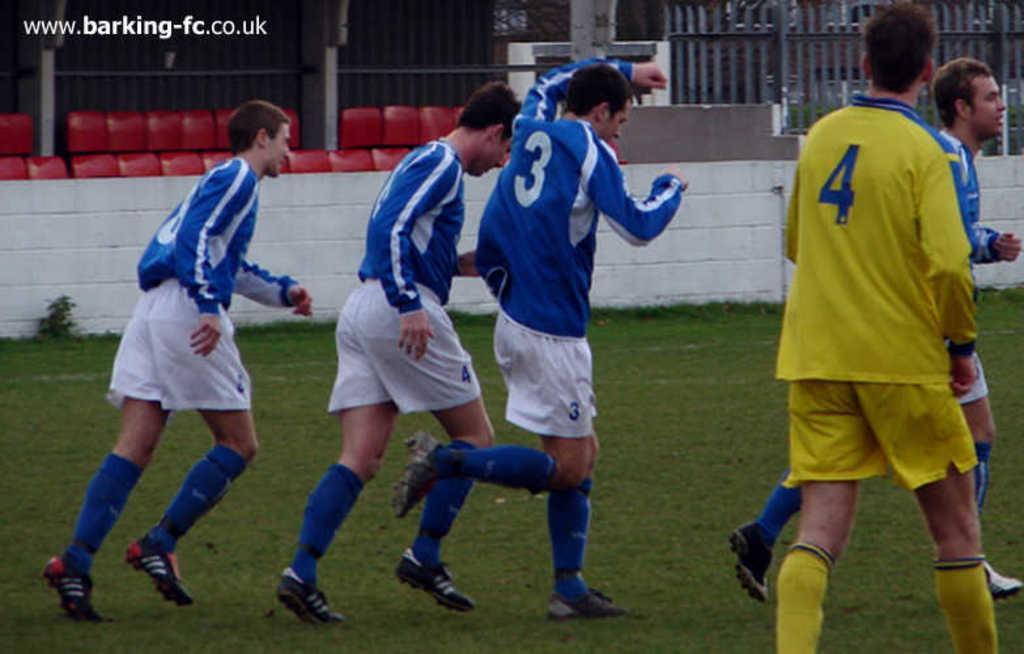In one or two sentences, can you explain what this image depicts? In this image there are persons running and there is a man walking wearing a yellow colour dress. In the background there is a wall and there are empty chairs and there is a fence and there is grass on the ground. 